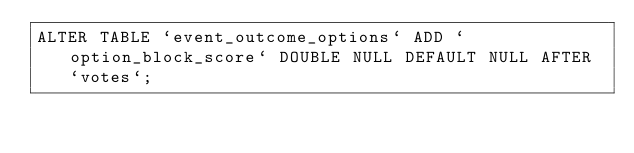<code> <loc_0><loc_0><loc_500><loc_500><_SQL_>ALTER TABLE `event_outcome_options` ADD `option_block_score` DOUBLE NULL DEFAULT NULL AFTER `votes`;</code> 